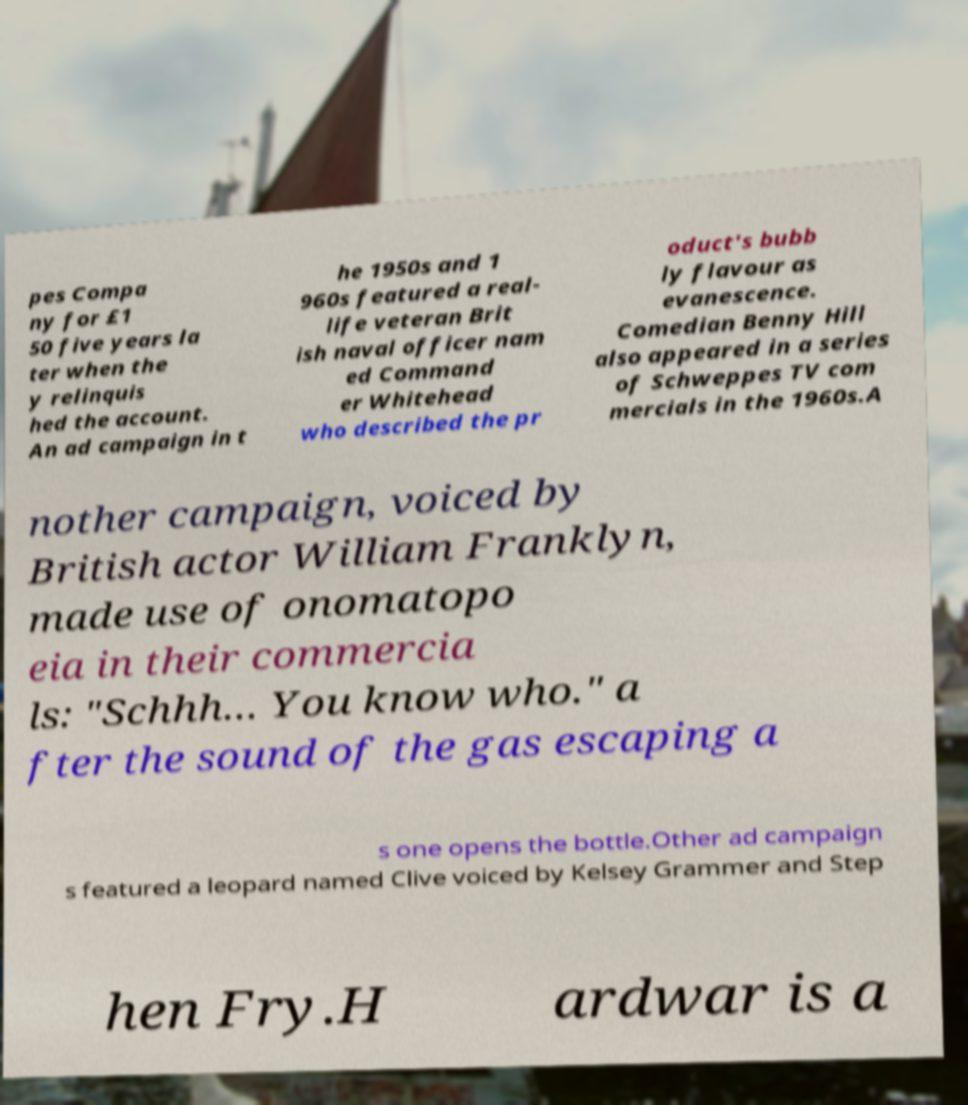Could you extract and type out the text from this image? pes Compa ny for £1 50 five years la ter when the y relinquis hed the account. An ad campaign in t he 1950s and 1 960s featured a real- life veteran Brit ish naval officer nam ed Command er Whitehead who described the pr oduct's bubb ly flavour as evanescence. Comedian Benny Hill also appeared in a series of Schweppes TV com mercials in the 1960s.A nother campaign, voiced by British actor William Franklyn, made use of onomatopo eia in their commercia ls: "Schhh… You know who." a fter the sound of the gas escaping a s one opens the bottle.Other ad campaign s featured a leopard named Clive voiced by Kelsey Grammer and Step hen Fry.H ardwar is a 